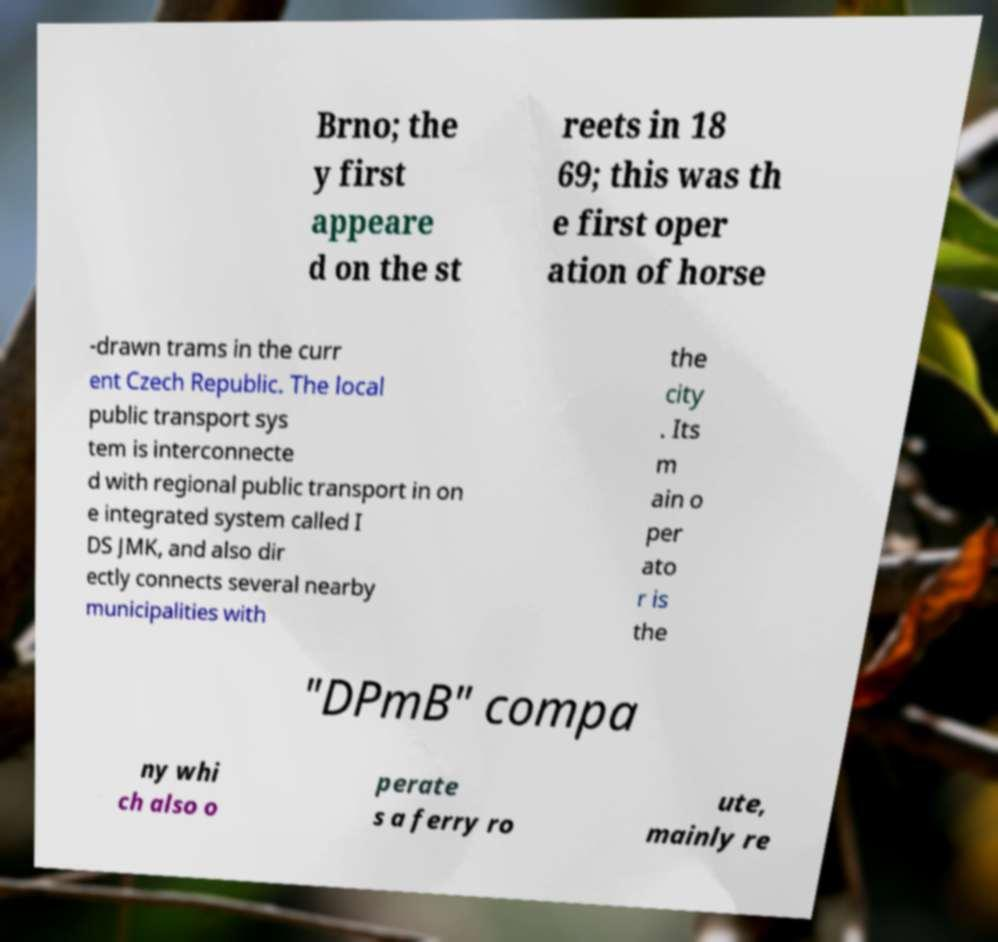Please read and relay the text visible in this image. What does it say? Brno; the y first appeare d on the st reets in 18 69; this was th e first oper ation of horse -drawn trams in the curr ent Czech Republic. The local public transport sys tem is interconnecte d with regional public transport in on e integrated system called I DS JMK, and also dir ectly connects several nearby municipalities with the city . Its m ain o per ato r is the "DPmB" compa ny whi ch also o perate s a ferry ro ute, mainly re 